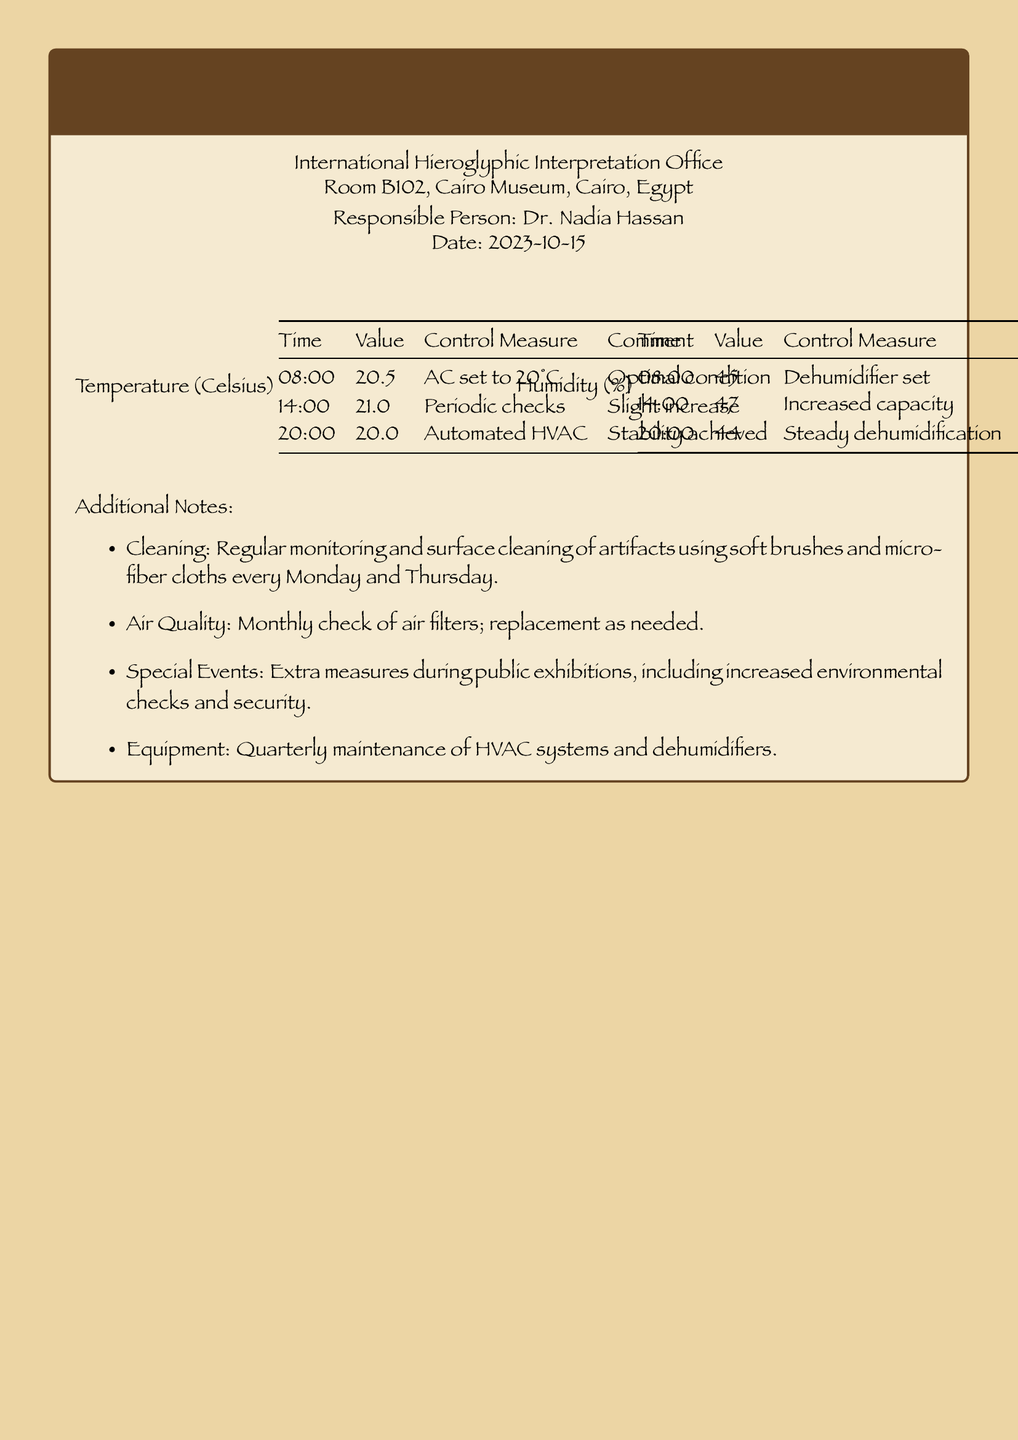what is the date of the log? The date is specified at the beginning of the log as the date the entries were made.
Answer: 2023-10-15 who is the responsible person? The document lists the person in charge of the maintenance log of environmental conditions.
Answer: Dr. Nadia Hassan what was the temperature at 14:00? The temperature for that specific time is recorded in the temperature section of the document.
Answer: 21.0 what control measure was taken at 08:00 for humidity? The control measure for humidity at that specific time is mentioned in the humidity section.
Answer: Dehumidifier set what was the humidity level at 20:00? This information is found in the humidity section specifying the reading taken at that time.
Answer: 44 how many degrees Celsius does the AC get set to? The AC setting is mentioned in the temperature section as a specific temperature used for control measures.
Answer: 20°C what cleaning method is used for artifacts? The document outlines the cleaning procedures specified for maintenance of artifacts.
Answer: Soft brushes and micro-fiber cloths how often are air filters checked? This information can be found under the additional notes section regarding air quality monitoring.
Answer: Monthly what extra measures are taken during public exhibitions? The document notes specific actions taken during special events, which refer to increased checks and security.
Answer: Increased environmental checks and security 